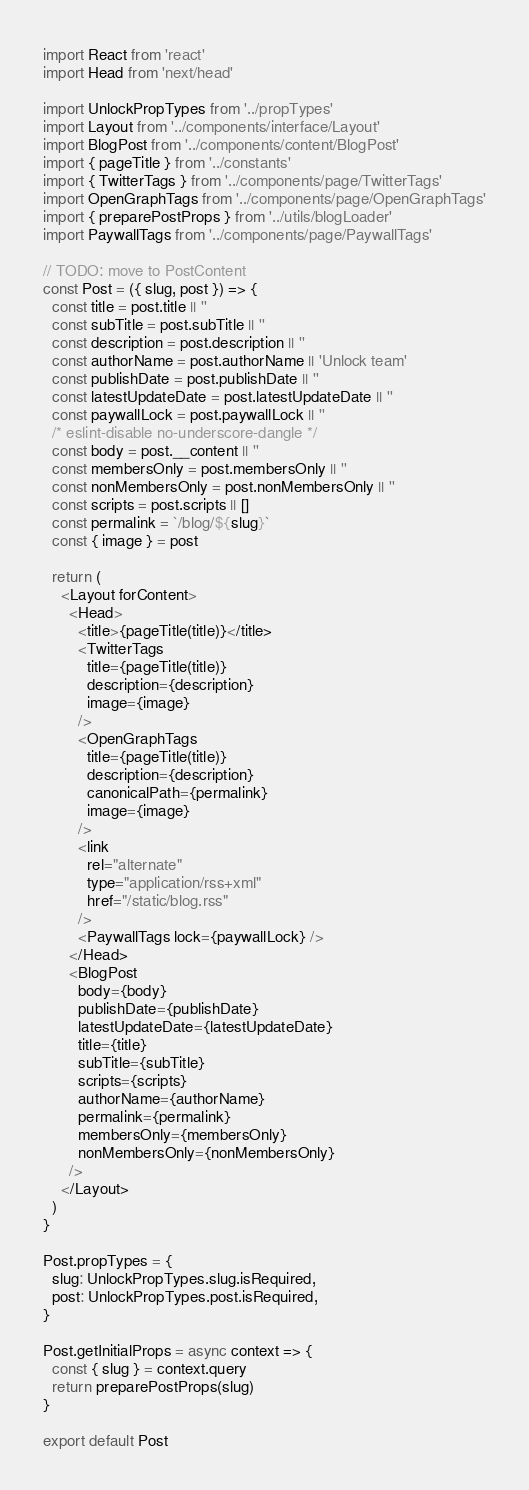Convert code to text. <code><loc_0><loc_0><loc_500><loc_500><_JavaScript_>import React from 'react'
import Head from 'next/head'

import UnlockPropTypes from '../propTypes'
import Layout from '../components/interface/Layout'
import BlogPost from '../components/content/BlogPost'
import { pageTitle } from '../constants'
import { TwitterTags } from '../components/page/TwitterTags'
import OpenGraphTags from '../components/page/OpenGraphTags'
import { preparePostProps } from '../utils/blogLoader'
import PaywallTags from '../components/page/PaywallTags'

// TODO: move to PostContent
const Post = ({ slug, post }) => {
  const title = post.title || ''
  const subTitle = post.subTitle || ''
  const description = post.description || ''
  const authorName = post.authorName || 'Unlock team'
  const publishDate = post.publishDate || ''
  const latestUpdateDate = post.latestUpdateDate || ''
  const paywallLock = post.paywallLock || ''
  /* eslint-disable no-underscore-dangle */
  const body = post.__content || ''
  const membersOnly = post.membersOnly || ''
  const nonMembersOnly = post.nonMembersOnly || ''
  const scripts = post.scripts || []
  const permalink = `/blog/${slug}`
  const { image } = post

  return (
    <Layout forContent>
      <Head>
        <title>{pageTitle(title)}</title>
        <TwitterTags
          title={pageTitle(title)}
          description={description}
          image={image}
        />
        <OpenGraphTags
          title={pageTitle(title)}
          description={description}
          canonicalPath={permalink}
          image={image}
        />
        <link
          rel="alternate"
          type="application/rss+xml"
          href="/static/blog.rss"
        />
        <PaywallTags lock={paywallLock} />
      </Head>
      <BlogPost
        body={body}
        publishDate={publishDate}
        latestUpdateDate={latestUpdateDate}
        title={title}
        subTitle={subTitle}
        scripts={scripts}
        authorName={authorName}
        permalink={permalink}
        membersOnly={membersOnly}
        nonMembersOnly={nonMembersOnly}
      />
    </Layout>
  )
}

Post.propTypes = {
  slug: UnlockPropTypes.slug.isRequired,
  post: UnlockPropTypes.post.isRequired,
}

Post.getInitialProps = async context => {
  const { slug } = context.query
  return preparePostProps(slug)
}

export default Post
</code> 